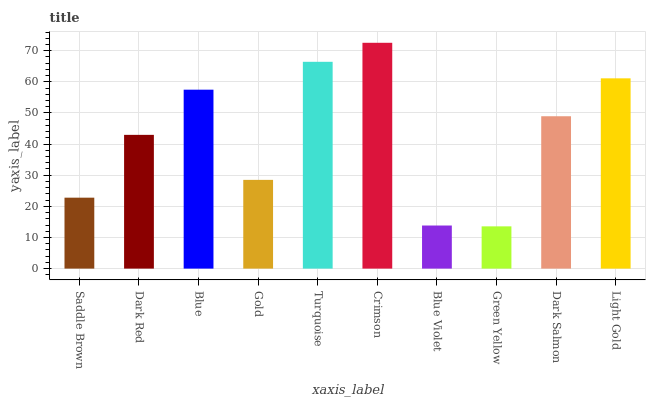Is Green Yellow the minimum?
Answer yes or no. Yes. Is Crimson the maximum?
Answer yes or no. Yes. Is Dark Red the minimum?
Answer yes or no. No. Is Dark Red the maximum?
Answer yes or no. No. Is Dark Red greater than Saddle Brown?
Answer yes or no. Yes. Is Saddle Brown less than Dark Red?
Answer yes or no. Yes. Is Saddle Brown greater than Dark Red?
Answer yes or no. No. Is Dark Red less than Saddle Brown?
Answer yes or no. No. Is Dark Salmon the high median?
Answer yes or no. Yes. Is Dark Red the low median?
Answer yes or no. Yes. Is Blue Violet the high median?
Answer yes or no. No. Is Green Yellow the low median?
Answer yes or no. No. 